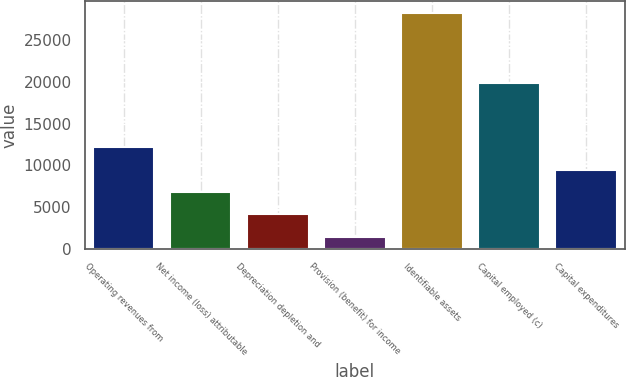Convert chart to OTSL. <chart><loc_0><loc_0><loc_500><loc_500><bar_chart><fcel>Operating revenues from<fcel>Net income (loss) attributable<fcel>Depreciation depletion and<fcel>Provision (benefit) for income<fcel>Identifiable assets<fcel>Capital employed (c)<fcel>Capital expenditures<nl><fcel>12147<fcel>6782<fcel>4099.5<fcel>1417<fcel>28242<fcel>19803<fcel>9464.5<nl></chart> 